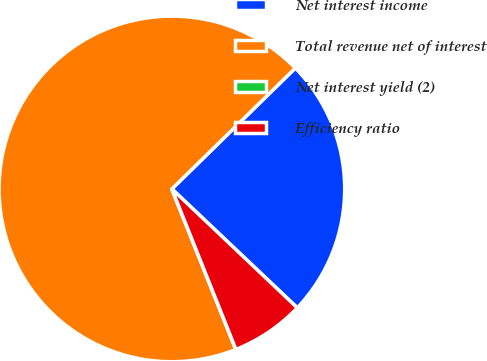Convert chart. <chart><loc_0><loc_0><loc_500><loc_500><pie_chart><fcel>Net interest income<fcel>Total revenue net of interest<fcel>Net interest yield (2)<fcel>Efficiency ratio<nl><fcel>24.41%<fcel>68.71%<fcel>0.01%<fcel>6.88%<nl></chart> 